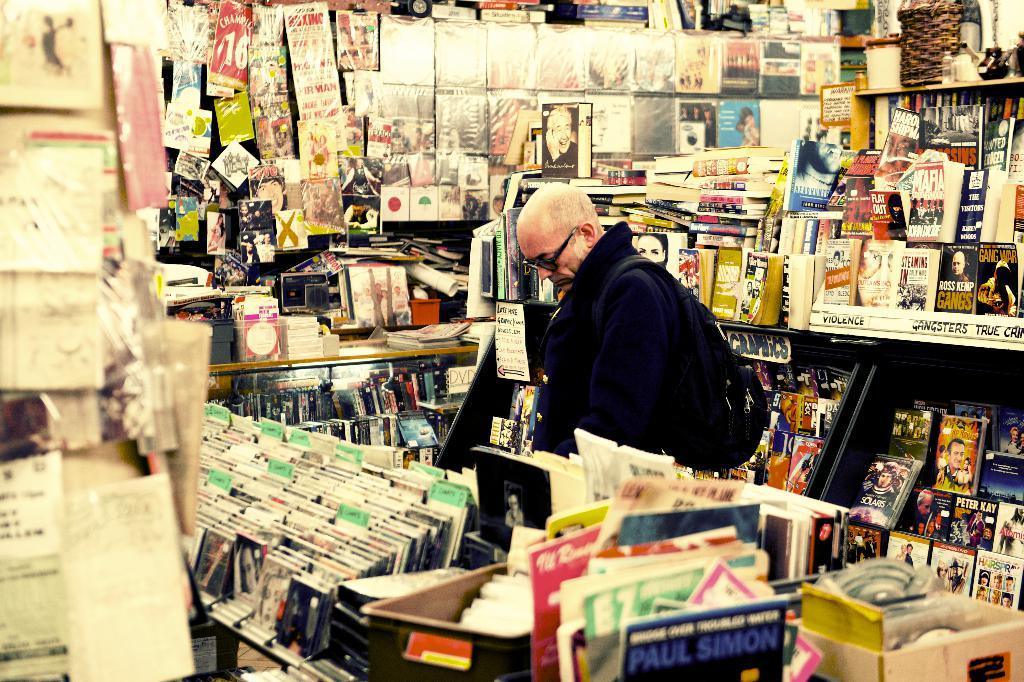Provide a one-sentence caption for the provided image. A man is looking through a shelf of records, including one by Paul Simon. 